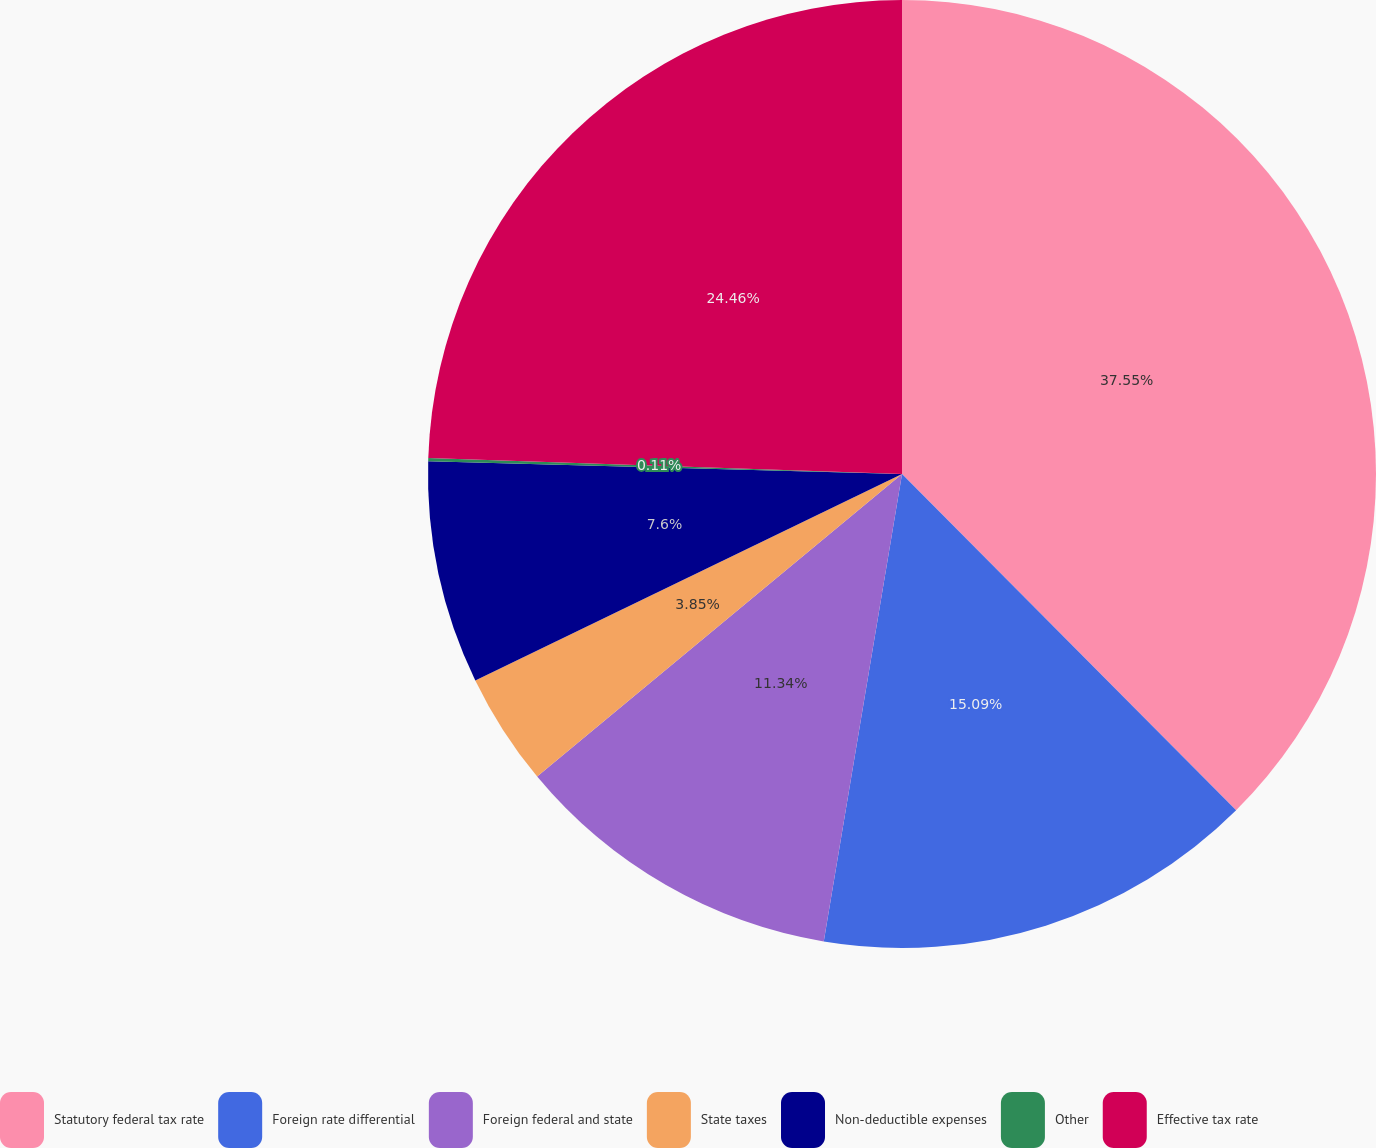Convert chart to OTSL. <chart><loc_0><loc_0><loc_500><loc_500><pie_chart><fcel>Statutory federal tax rate<fcel>Foreign rate differential<fcel>Foreign federal and state<fcel>State taxes<fcel>Non-deductible expenses<fcel>Other<fcel>Effective tax rate<nl><fcel>37.55%<fcel>15.09%<fcel>11.34%<fcel>3.85%<fcel>7.6%<fcel>0.11%<fcel>24.46%<nl></chart> 